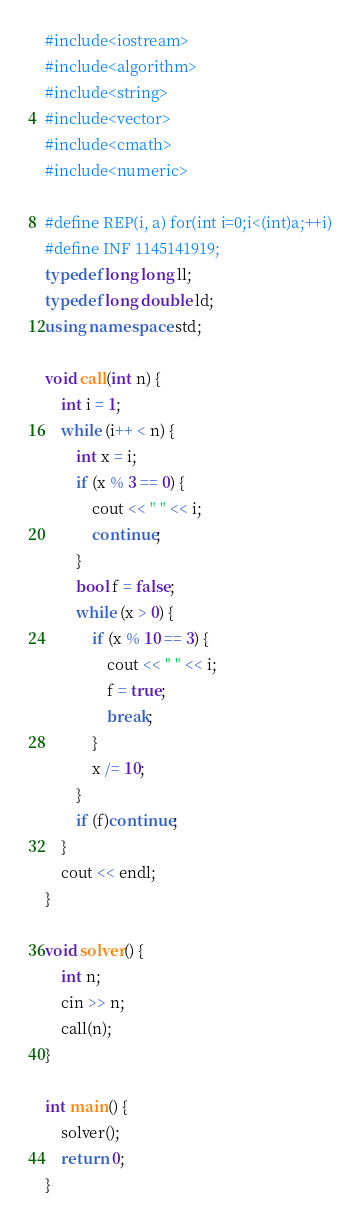<code> <loc_0><loc_0><loc_500><loc_500><_C++_>#include<iostream>
#include<algorithm>
#include<string>
#include<vector>
#include<cmath>
#include<numeric>

#define REP(i, a) for(int i=0;i<(int)a;++i)
#define INF 1145141919;
typedef long long ll;
typedef long double ld;
using namespace std;

void call(int n) {
    int i = 1;
    while (i++ < n) {
        int x = i;
        if (x % 3 == 0) {
            cout << " " << i;
            continue;
        }
        bool f = false;
        while (x > 0) {
            if (x % 10 == 3) {
                cout << " " << i;
                f = true;
                break;
            }
            x /= 10;
        }
        if (f)continue;
    }
    cout << endl;
}

void solver() {
    int n;
    cin >> n;
    call(n);
}

int main() {
    solver();
    return 0;
}</code> 